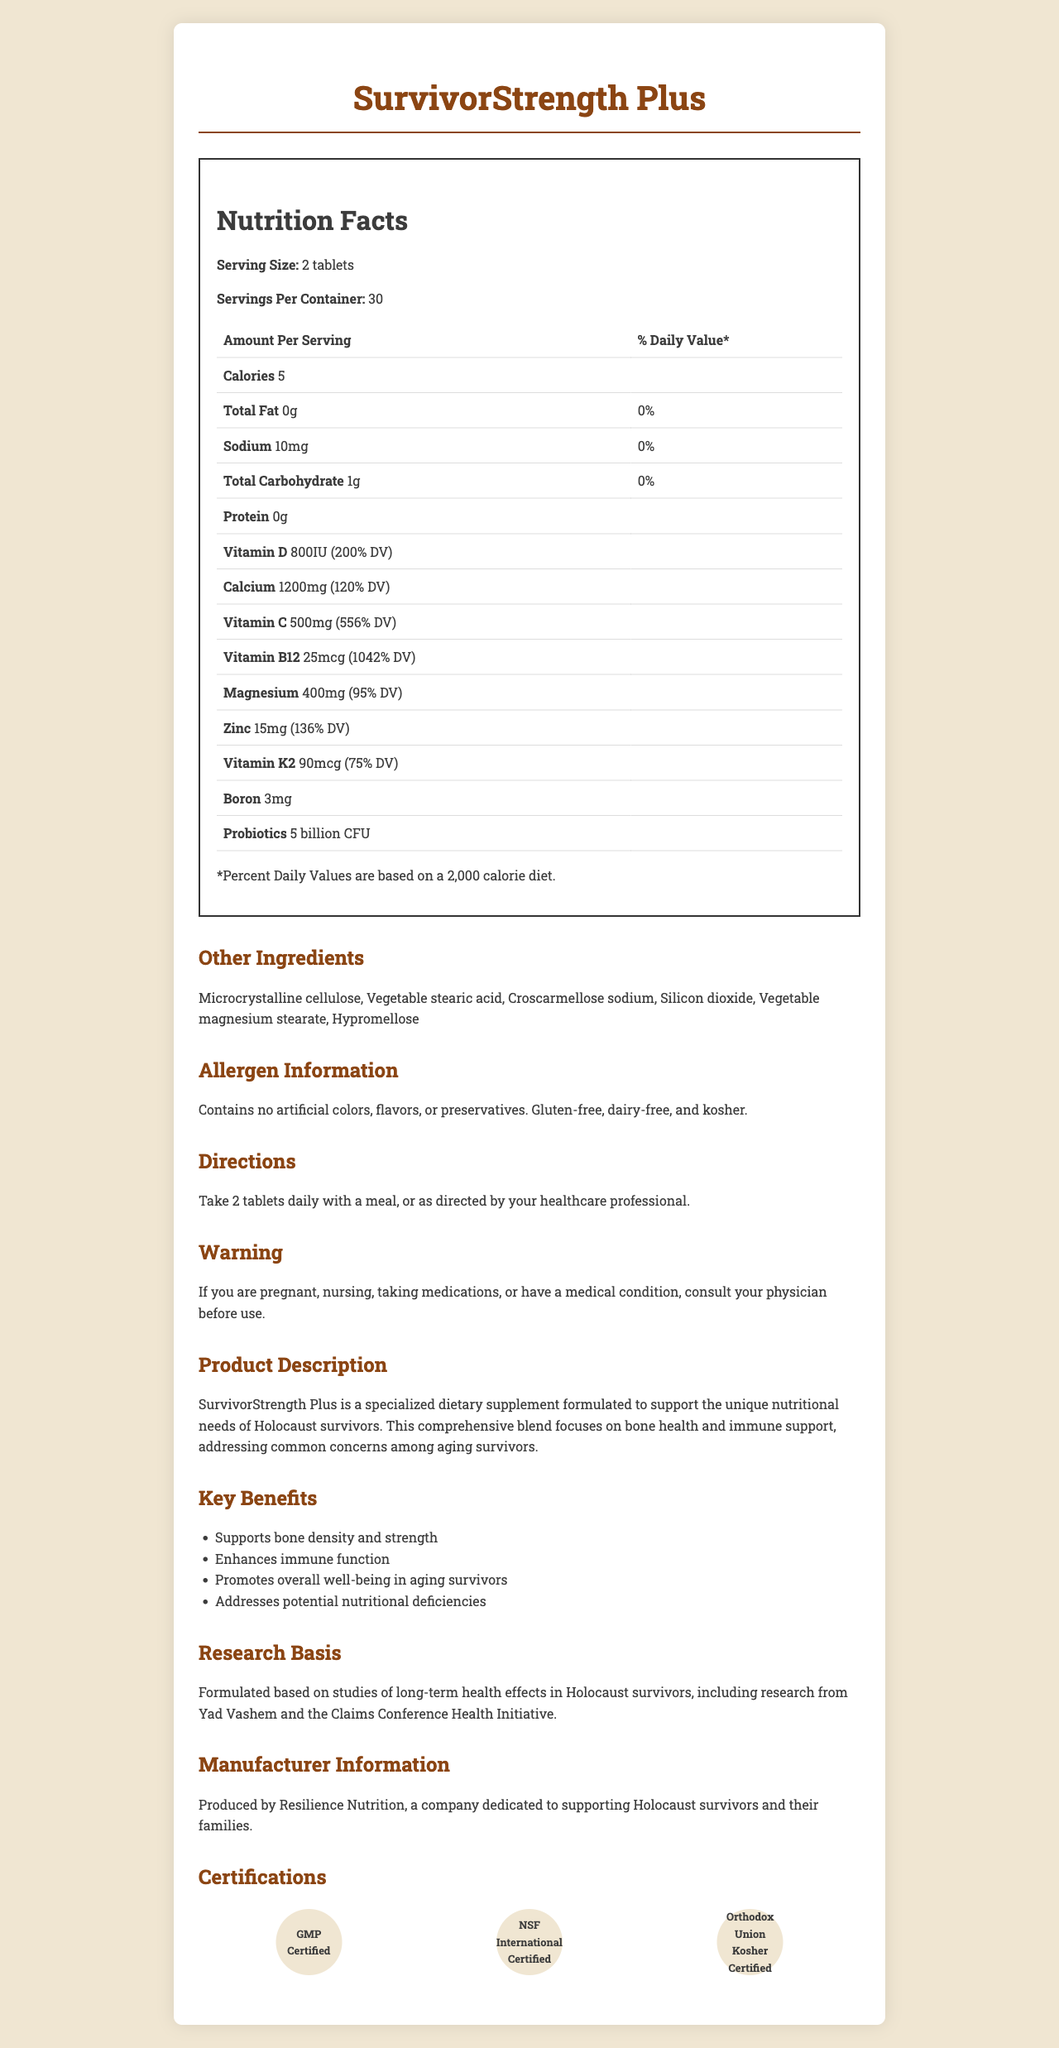what is the serving size of SurvivorStrength Plus? The serving size is clearly mentioned in the nutrition label under "Serving Size".
Answer: 2 tablets how much calcium is provided per serving? The nutrition label lists calcium content as 1200mg per serving.
Answer: 1200mg what is the primary focus of the SurvivorStrength Plus supplement? The product description explicitly states that it focuses on bone health and immune support.
Answer: Bone health and immune support how many servings are there in one container? The serving information section indicates that there are 30 servings per container.
Answer: 30 how many calories does one serving contain? The nutrition label lists the calorie content as 5 per serving.
Answer: 5 which vitamin has the highest percentage of daily value (DV)? A. Vitamin D B. Vitamin C C. Vitamin B12 D. Zinc The nutrition label indicates Vitamin B12 has 1042% DV, which is the highest among listed vitamins.
Answer: C. Vitamin B12 what is the main benefit of probiotics listed in SurvivorStrength Plus? A. Enhances immune function B. Supports bone density C. Reduces inflammation D. Improves digestion The key benefits section lists enhancing immune function, which is commonly associated with probiotics, among the options listed.
Answer: A. Enhances immune function is SurvivorStrength Plus suitable for someone with gluten intolerance? The allergen information states that the product is gluten-free.
Answer: Yes describe the key nutritional components of SurvivorStrength Plus. The nutrition label lists these components along with their amounts and percentage daily values.
Answer: SurvivorStrength Plus contains significant amounts of Vitamin D (800IU), Calcium (1200mg), Vitamin C (500mg), Vitamin B12 (25mcg), Magnesium (400mg), Zinc (15mg), Vitamin K2 (90mcg), and a probiotic blend of 5 billion CFU. can a pregnant woman take SurvivorStrength Plus without consulting a physician? The warning statement advises consultation with a physician if pregnant.
Answer: No what research is the formulation of SurvivorStrength Plus based on? The research basis section mentions that the formulation is based on studies of long-term health effects in Holocaust survivors.
Answer: Studies of long-term health effects in Holocaust survivors who manufactures SurvivorStrength Plus? The manufacturer info mentions Resilience Nutrition as the producer of the supplement.
Answer: Resilience Nutrition how should SurvivorStrength Plus be consumed for best results? The directions specify that 2 tablets should be taken daily with a meal.
Answer: Take 2 tablets daily with a meal what certifications does SurvivorStrength Plus have? The certifications section lists these three certifications.
Answer: GMP Certified, NSF International Certified, Orthodox Union Kosher Certified how many grams of protein are in one serving? The nutrition label clearly shows that there are 0 grams of protein per serving.
Answer: 0g what are the possible allergens present in SurvivorStrength Plus? The allergen info states that the product contains no artificial colors, flavors, or preservatives, and is gluten-free, dairy-free, and kosher.
Answer: None what are the key benefits of taking SurvivorStrength Plus? The key benefits section lists these four benefits.
Answer: Supports bone density and strength, Enhances immune function, Promotes overall well-being in aging survivors, Addresses potential nutritional deficiencies. how much vitamin K2 is in one serving and what is its % daily value? The nutrition label indicates that vitamin K2 content is 90mcg per serving with a daily value of 75%.
Answer: 90mcg, 75% DV is SurvivorStrength Plus certified by the FDA? The document does not mention FDA certification but lists other certifications such as GMP, NSF International, and Orthodox Union Kosher.
Answer: Not enough information summarize the main idea of the SurvivorStrength Plus document. The entire document is designed to inform about the various aspects of this supplement, confirming its appropriateness and efficacy for its target audience.
Answer: The document provides detailed information about SurvivorStrength Plus, a dietary supplement aimed at supporting bone health and immune function, particularly for Holocaust survivors. It covers the nutrition facts, serving instructions, key benefits, research basis, allergen information, and certifications, and emphasizes its formulation based on research focused on the long-term health effects in Holocaust survivors. 